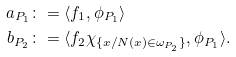Convert formula to latex. <formula><loc_0><loc_0><loc_500><loc_500>a _ { P _ { 1 } } & \colon = \langle f _ { 1 } , \phi _ { P _ { 1 } } \rangle \\ b _ { P _ { 2 } } & \colon = \langle f _ { 2 } \chi _ { \{ x / N ( x ) \in \omega _ { P _ { 2 } } \} } , \phi _ { P _ { 1 } } \rangle .</formula> 